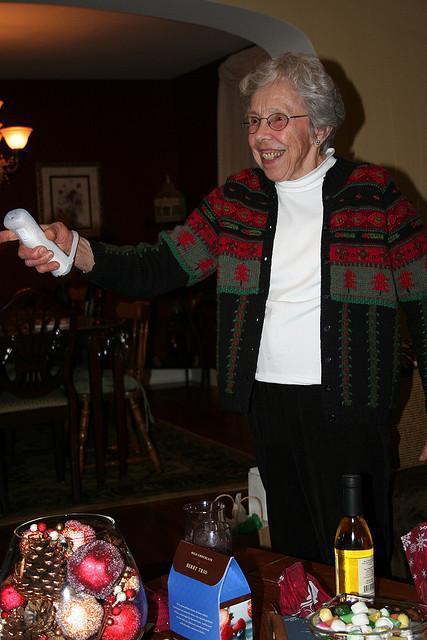How many bottles are there?
Give a very brief answer. 1. How many chairs are there?
Give a very brief answer. 2. 